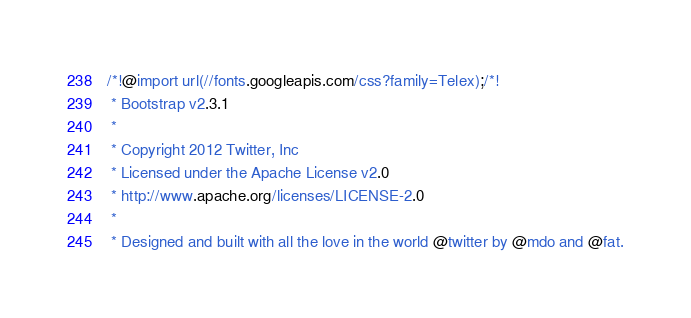<code> <loc_0><loc_0><loc_500><loc_500><_CSS_>/*!@import url(//fonts.googleapis.com/css?family=Telex);/*!
 * Bootstrap v2.3.1
 *
 * Copyright 2012 Twitter, Inc
 * Licensed under the Apache License v2.0
 * http://www.apache.org/licenses/LICENSE-2.0
 *
 * Designed and built with all the love in the world @twitter by @mdo and @fat.</code> 